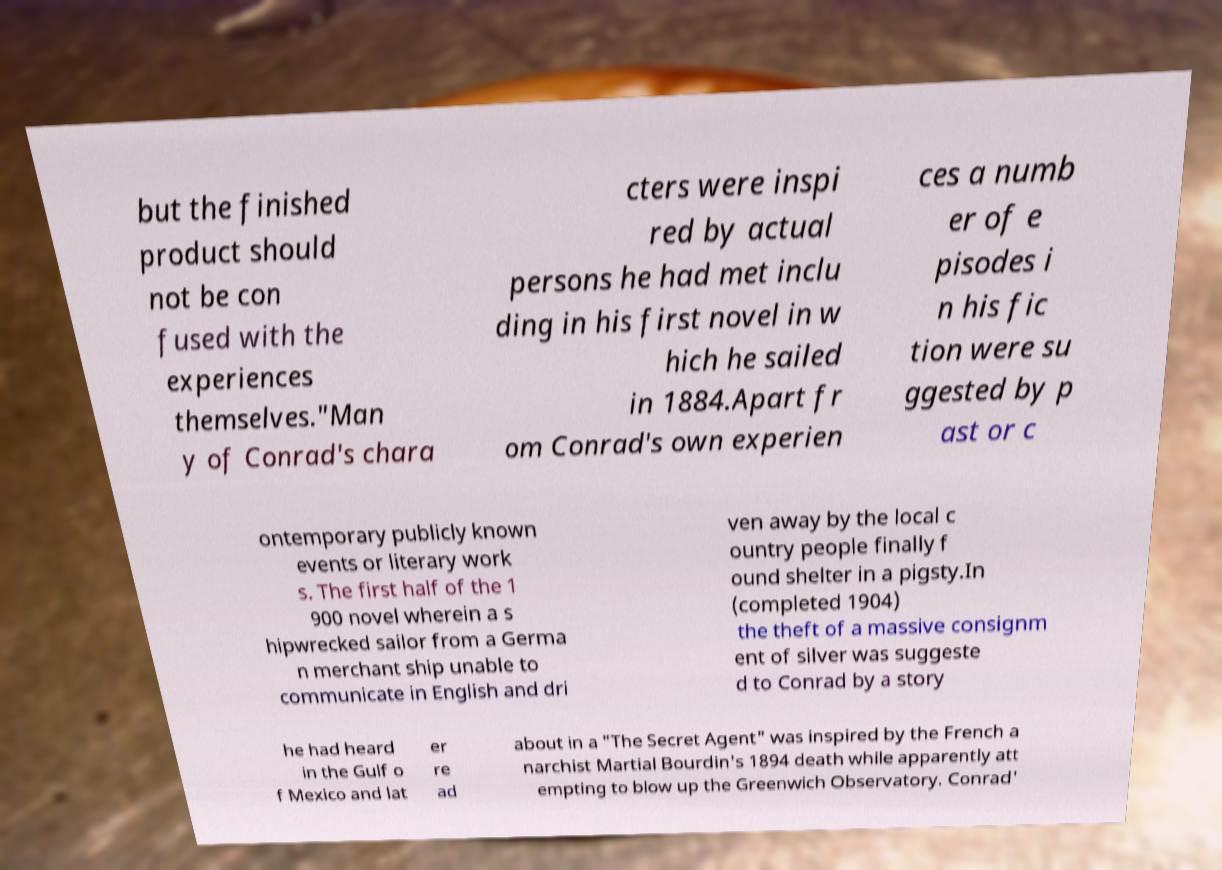Can you read and provide the text displayed in the image?This photo seems to have some interesting text. Can you extract and type it out for me? but the finished product should not be con fused with the experiences themselves."Man y of Conrad's chara cters were inspi red by actual persons he had met inclu ding in his first novel in w hich he sailed in 1884.Apart fr om Conrad's own experien ces a numb er of e pisodes i n his fic tion were su ggested by p ast or c ontemporary publicly known events or literary work s. The first half of the 1 900 novel wherein a s hipwrecked sailor from a Germa n merchant ship unable to communicate in English and dri ven away by the local c ountry people finally f ound shelter in a pigsty.In (completed 1904) the theft of a massive consignm ent of silver was suggeste d to Conrad by a story he had heard in the Gulf o f Mexico and lat er re ad about in a "The Secret Agent" was inspired by the French a narchist Martial Bourdin's 1894 death while apparently att empting to blow up the Greenwich Observatory. Conrad' 